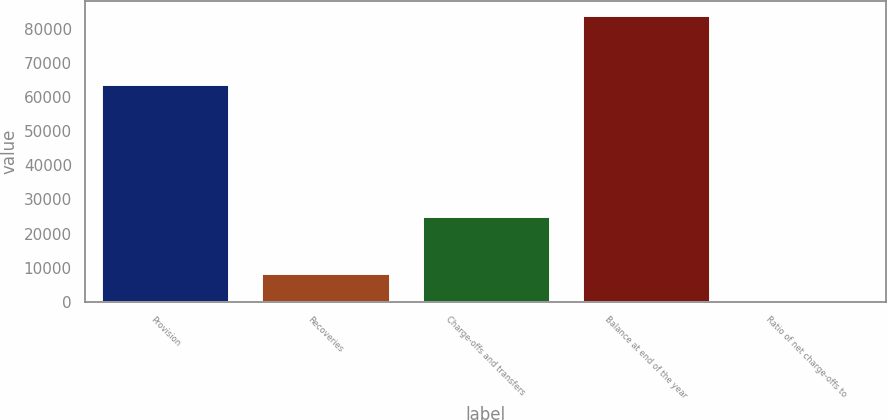Convert chart to OTSL. <chart><loc_0><loc_0><loc_500><loc_500><bar_chart><fcel>Provision<fcel>Recoveries<fcel>Charge-offs and transfers<fcel>Balance at end of the year<fcel>Ratio of net charge-offs to<nl><fcel>63897<fcel>8409.82<fcel>25279<fcel>84073<fcel>2.8<nl></chart> 